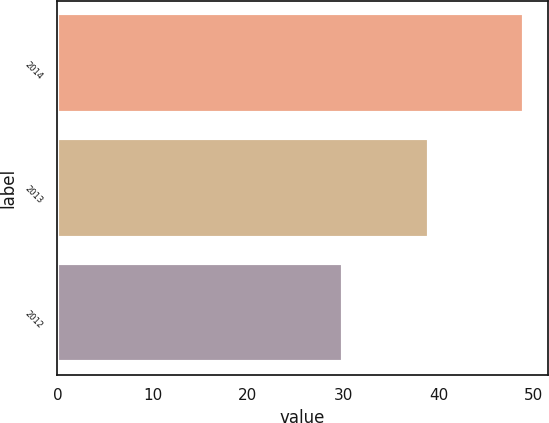Convert chart. <chart><loc_0><loc_0><loc_500><loc_500><bar_chart><fcel>2014<fcel>2013<fcel>2012<nl><fcel>49<fcel>39<fcel>30<nl></chart> 